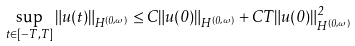<formula> <loc_0><loc_0><loc_500><loc_500>\sup _ { t \in [ - T , T ] } \| u ( t ) \| _ { H ^ { ( 0 , \omega ) } } \leq C \| u ( 0 ) \| _ { H ^ { ( 0 , \omega ) } } + C T \| u ( 0 ) \| ^ { 2 } _ { H ^ { ( 0 , \omega ) } }</formula> 